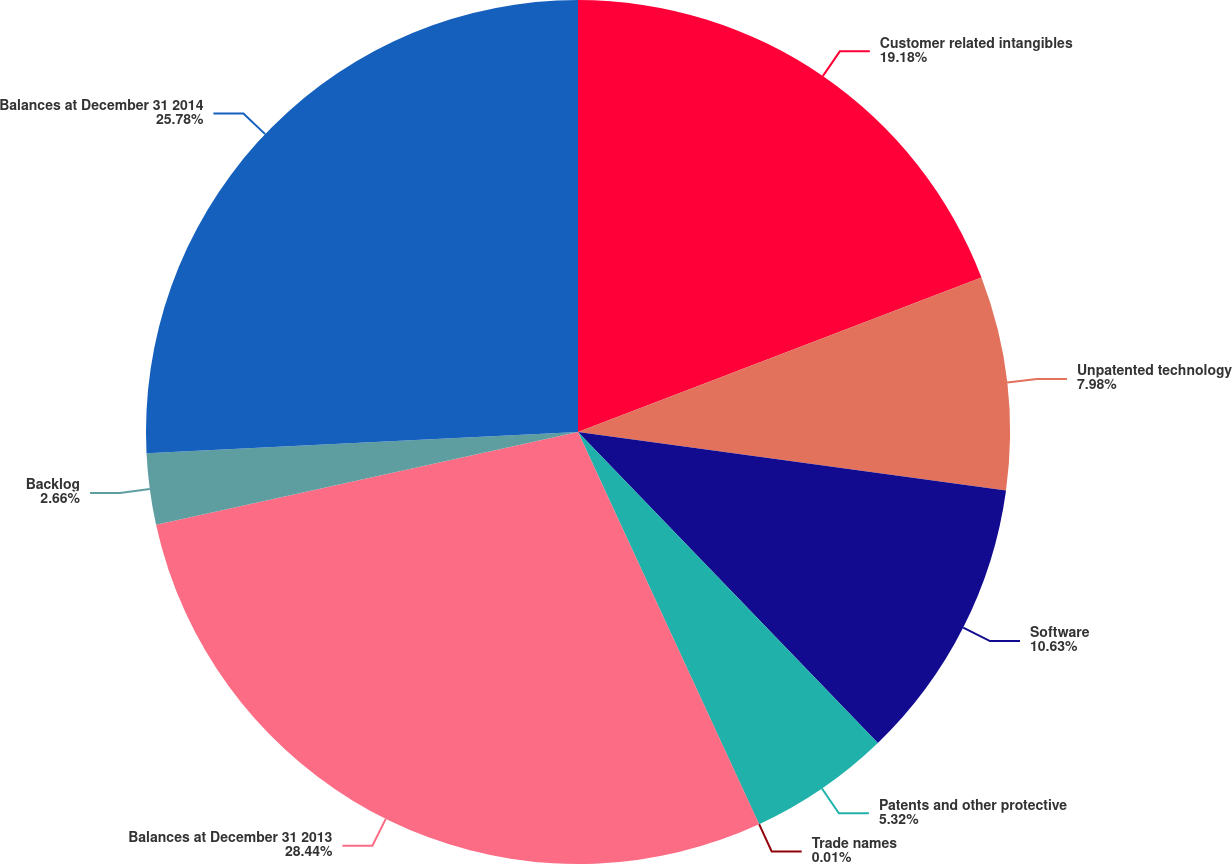Convert chart to OTSL. <chart><loc_0><loc_0><loc_500><loc_500><pie_chart><fcel>Customer related intangibles<fcel>Unpatented technology<fcel>Software<fcel>Patents and other protective<fcel>Trade names<fcel>Balances at December 31 2013<fcel>Backlog<fcel>Balances at December 31 2014<nl><fcel>19.18%<fcel>7.98%<fcel>10.63%<fcel>5.32%<fcel>0.01%<fcel>28.44%<fcel>2.66%<fcel>25.78%<nl></chart> 